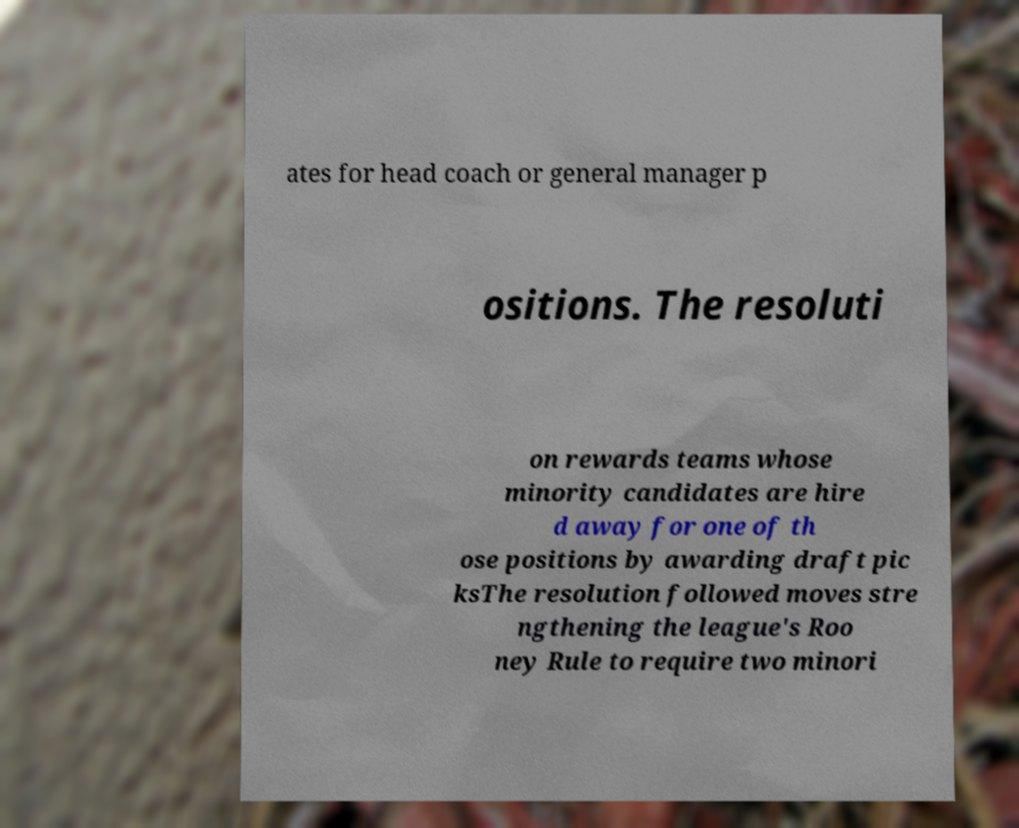For documentation purposes, I need the text within this image transcribed. Could you provide that? ates for head coach or general manager p ositions. The resoluti on rewards teams whose minority candidates are hire d away for one of th ose positions by awarding draft pic ksThe resolution followed moves stre ngthening the league's Roo ney Rule to require two minori 